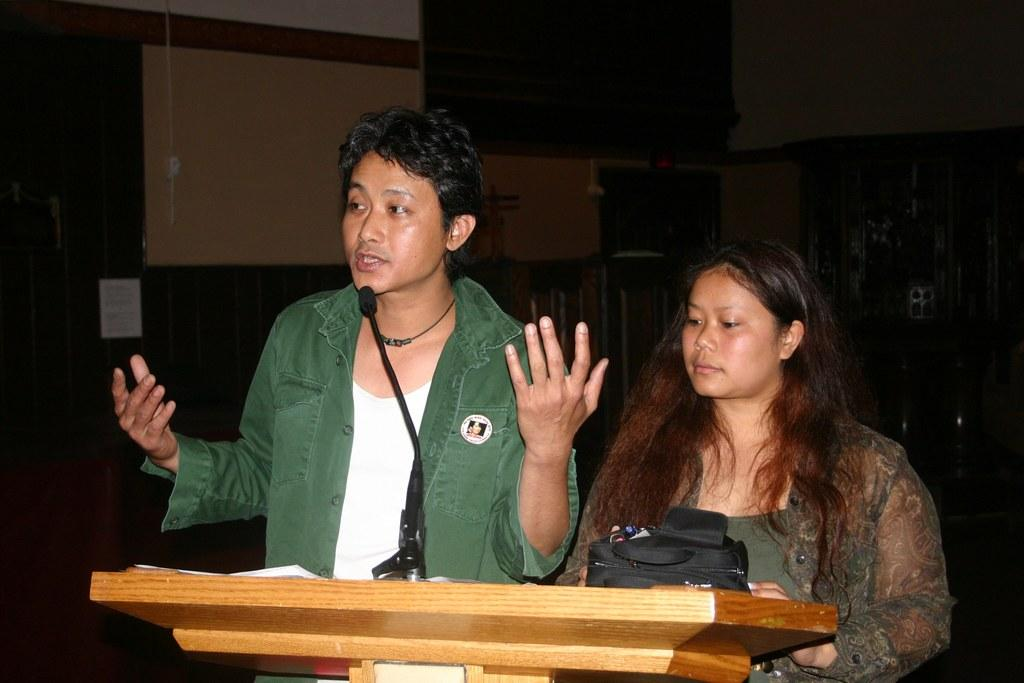How many people are present in the image? There is a man and a woman present in the image. What are the man and woman doing in the image? Both the man and woman are standing at a podium. What can be seen on the podium? There is a microphone and a bag on the podium. What is visible in the background of the image? There is a wall in the backdrop of the image. What type of quilt is being used to cover the microphone in the image? There is no quilt present in the image, and the microphone is not covered. What thought is the man having while standing at the podium? The image does not provide information about the thoughts of the man or woman, so it cannot be determined from the image. 